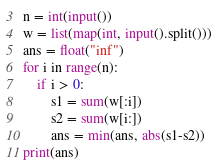Convert code to text. <code><loc_0><loc_0><loc_500><loc_500><_Python_>n = int(input())
w = list(map(int, input().split()))
ans = float("inf")
for i in range(n):
    if i > 0:
        s1 = sum(w[:i])
        s2 = sum(w[i:])
        ans = min(ans, abs(s1-s2))
print(ans)</code> 